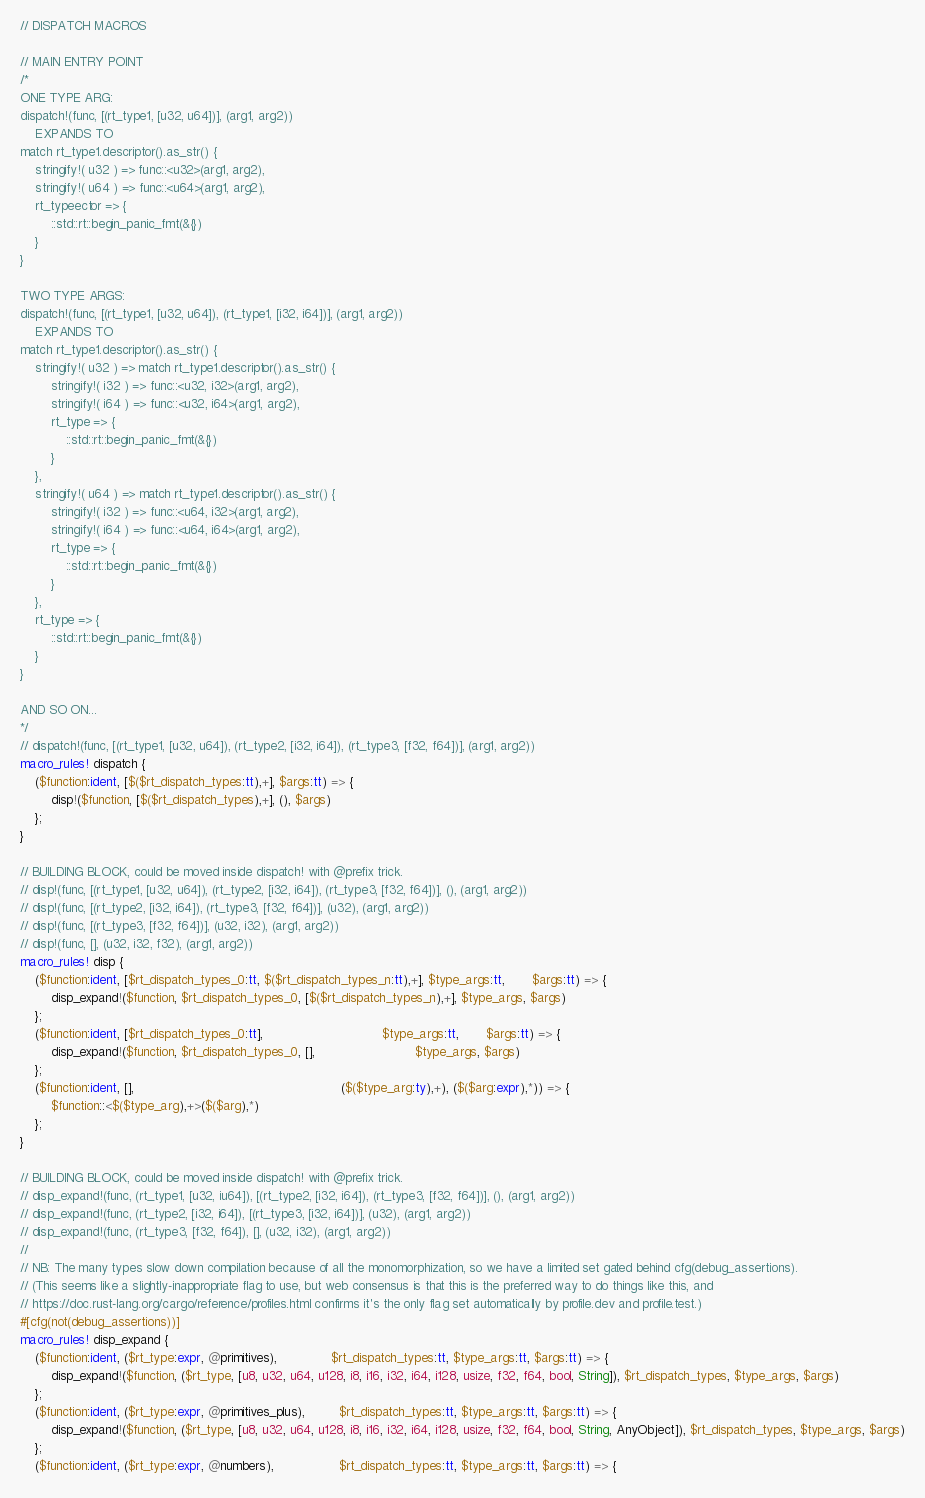Convert code to text. <code><loc_0><loc_0><loc_500><loc_500><_Rust_>// DISPATCH MACROS

// MAIN ENTRY POINT
/*
ONE TYPE ARG:
dispatch!(func, [(rt_type1, [u32, u64])], (arg1, arg2))
    EXPANDS TO
match rt_type1.descriptor().as_str() {
    stringify!( u32 ) => func::<u32>(arg1, arg2),
    stringify!( u64 ) => func::<u64>(arg1, arg2),
    rt_typeector => {
        ::std::rt::begin_panic_fmt(&{})
    }
}

TWO TYPE ARGS:
dispatch!(func, [(rt_type1, [u32, u64]), (rt_type1, [i32, i64])], (arg1, arg2))
    EXPANDS TO
match rt_type1.descriptor().as_str() {
    stringify!( u32 ) => match rt_type1.descriptor().as_str() {
        stringify!( i32 ) => func::<u32, i32>(arg1, arg2),
        stringify!( i64 ) => func::<u32, i64>(arg1, arg2),
        rt_type => {
            ::std::rt::begin_panic_fmt(&{})
        }
    },
    stringify!( u64 ) => match rt_type1.descriptor().as_str() {
        stringify!( i32 ) => func::<u64, i32>(arg1, arg2),
        stringify!( i64 ) => func::<u64, i64>(arg1, arg2),
        rt_type => {
            ::std::rt::begin_panic_fmt(&{})
        }
    },
    rt_type => {
        ::std::rt::begin_panic_fmt(&{})
    }
}

AND SO ON...
*/
// dispatch!(func, [(rt_type1, [u32, u64]), (rt_type2, [i32, i64]), (rt_type3, [f32, f64])], (arg1, arg2))
macro_rules! dispatch {
    ($function:ident, [$($rt_dispatch_types:tt),+], $args:tt) => {
        disp!($function, [$($rt_dispatch_types),+], (), $args)
    };
}

// BUILDING BLOCK, could be moved inside dispatch! with @prefix trick.
// disp!(func, [(rt_type1, [u32, u64]), (rt_type2, [i32, i64]), (rt_type3, [f32, f64])], (), (arg1, arg2))
// disp!(func, [(rt_type2, [i32, i64]), (rt_type3, [f32, f64])], (u32), (arg1, arg2))
// disp!(func, [(rt_type3, [f32, f64])], (u32, i32), (arg1, arg2))
// disp!(func, [], (u32, i32, f32), (arg1, arg2))
macro_rules! disp {
    ($function:ident, [$rt_dispatch_types_0:tt, $($rt_dispatch_types_n:tt),+], $type_args:tt,       $args:tt) => {
        disp_expand!($function, $rt_dispatch_types_0, [$($rt_dispatch_types_n),+], $type_args, $args)
    };
    ($function:ident, [$rt_dispatch_types_0:tt],                               $type_args:tt,       $args:tt) => {
        disp_expand!($function, $rt_dispatch_types_0, [],                          $type_args, $args)
    };
    ($function:ident, [],                                                      ($($type_arg:ty),+), ($($arg:expr),*)) => {
        $function::<$($type_arg),+>($($arg),*)
    };
}

// BUILDING BLOCK, could be moved inside dispatch! with @prefix trick.
// disp_expand!(func, (rt_type1, [u32, iu64]), [(rt_type2, [i32, i64]), (rt_type3, [f32, f64])], (), (arg1, arg2))
// disp_expand!(func, (rt_type2, [i32, i64]), [(rt_type3, [i32, i64])], (u32), (arg1, arg2))
// disp_expand!(func, (rt_type3, [f32, f64]), [], (u32, i32), (arg1, arg2))
//
// NB: The many types slow down compilation because of all the monomorphization, so we have a limited set gated behind cfg(debug_assertions).
// (This seems like a slightly-inappropriate flag to use, but web consensus is that this is the preferred way to do things like this, and
// https://doc.rust-lang.org/cargo/reference/profiles.html confirms it's the only flag set automatically by profile.dev and profile.test.)
#[cfg(not(debug_assertions))]
macro_rules! disp_expand {
    ($function:ident, ($rt_type:expr, @primitives),              $rt_dispatch_types:tt, $type_args:tt, $args:tt) => {
        disp_expand!($function, ($rt_type, [u8, u32, u64, u128, i8, i16, i32, i64, i128, usize, f32, f64, bool, String]), $rt_dispatch_types, $type_args, $args)
    };
    ($function:ident, ($rt_type:expr, @primitives_plus),         $rt_dispatch_types:tt, $type_args:tt, $args:tt) => {
        disp_expand!($function, ($rt_type, [u8, u32, u64, u128, i8, i16, i32, i64, i128, usize, f32, f64, bool, String, AnyObject]), $rt_dispatch_types, $type_args, $args)
    };
    ($function:ident, ($rt_type:expr, @numbers),                 $rt_dispatch_types:tt, $type_args:tt, $args:tt) => {</code> 